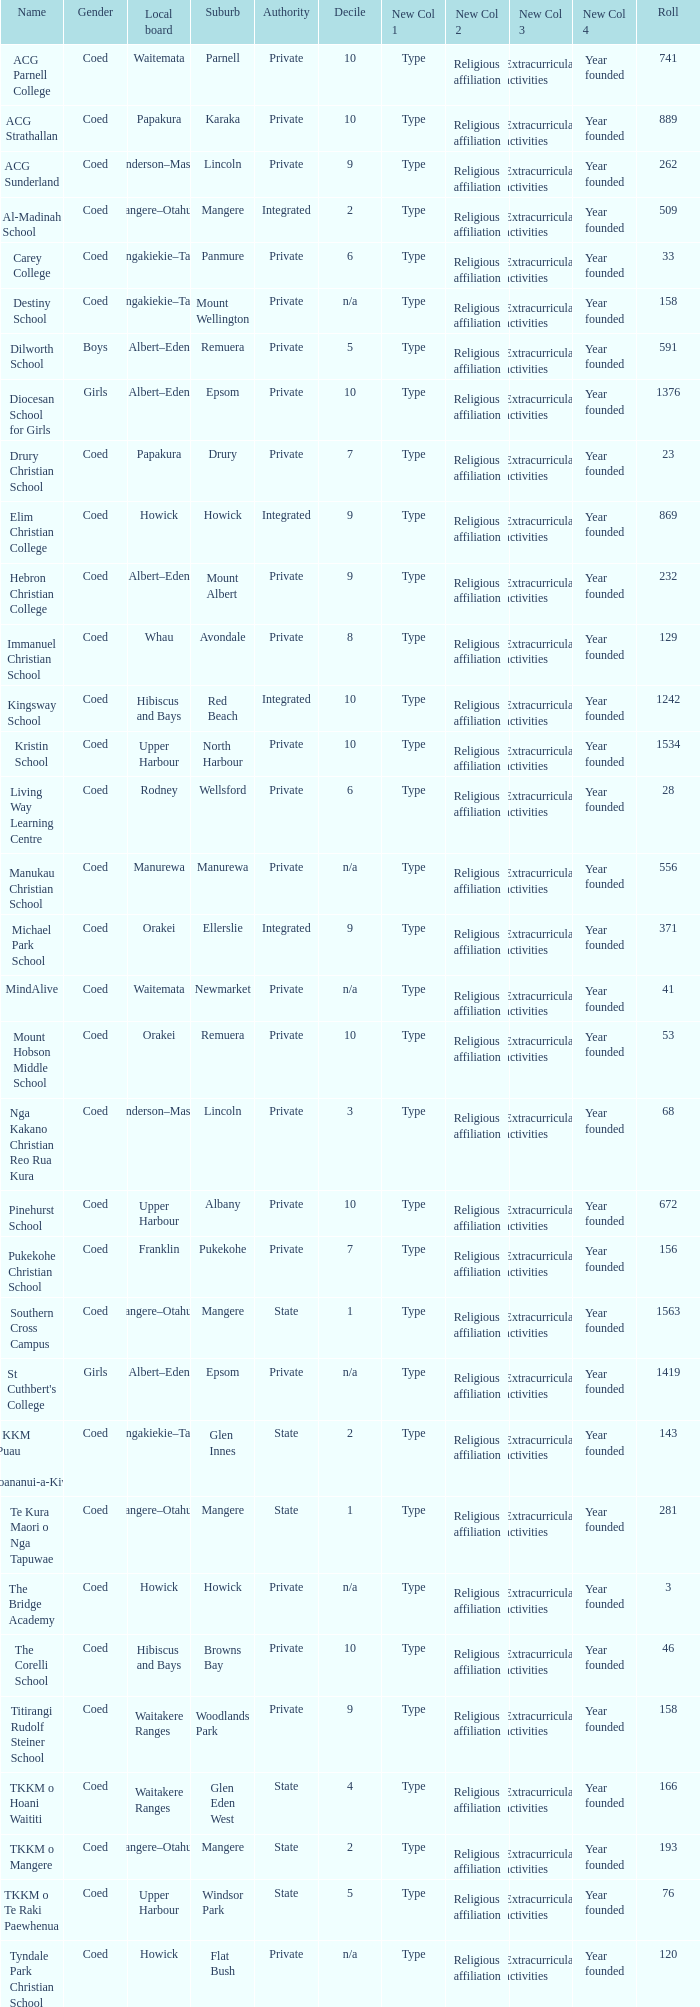What gender has a local board of albert–eden with a roll of more than 232 and Decile of 5? Boys. 